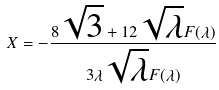Convert formula to latex. <formula><loc_0><loc_0><loc_500><loc_500>X = - \frac { 8 \sqrt { 3 } + 1 2 \sqrt { \lambda } F ( \lambda ) } { 3 \lambda \sqrt { \lambda } F ( \lambda ) }</formula> 